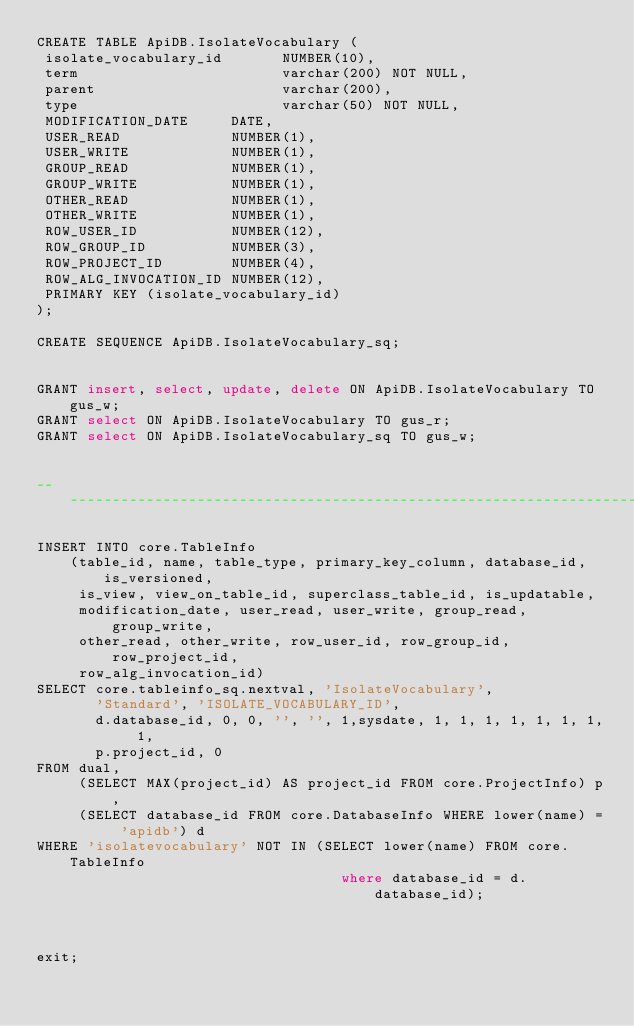Convert code to text. <code><loc_0><loc_0><loc_500><loc_500><_SQL_>CREATE TABLE ApiDB.IsolateVocabulary (
 isolate_vocabulary_id       NUMBER(10),
 term                        varchar(200) NOT NULL,
 parent                      varchar(200),
 type                        varchar(50) NOT NULL,
 MODIFICATION_DATE     DATE,
 USER_READ             NUMBER(1),
 USER_WRITE            NUMBER(1),
 GROUP_READ            NUMBER(1),
 GROUP_WRITE           NUMBER(1),
 OTHER_READ            NUMBER(1),
 OTHER_WRITE           NUMBER(1),
 ROW_USER_ID           NUMBER(12),
 ROW_GROUP_ID          NUMBER(3),
 ROW_PROJECT_ID        NUMBER(4),
 ROW_ALG_INVOCATION_ID NUMBER(12),
 PRIMARY KEY (isolate_vocabulary_id)
);

CREATE SEQUENCE ApiDB.IsolateVocabulary_sq;


GRANT insert, select, update, delete ON ApiDB.IsolateVocabulary TO gus_w;
GRANT select ON ApiDB.IsolateVocabulary TO gus_r;
GRANT select ON ApiDB.IsolateVocabulary_sq TO gus_w;


------------------------------------------------------------------------------

INSERT INTO core.TableInfo
    (table_id, name, table_type, primary_key_column, database_id, is_versioned,
     is_view, view_on_table_id, superclass_table_id, is_updatable, 
     modification_date, user_read, user_write, group_read, group_write, 
     other_read, other_write, row_user_id, row_group_id, row_project_id, 
     row_alg_invocation_id)
SELECT core.tableinfo_sq.nextval, 'IsolateVocabulary',
       'Standard', 'ISOLATE_VOCABULARY_ID',
       d.database_id, 0, 0, '', '', 1,sysdate, 1, 1, 1, 1, 1, 1, 1, 1,
       p.project_id, 0
FROM dual,
     (SELECT MAX(project_id) AS project_id FROM core.ProjectInfo) p,
     (SELECT database_id FROM core.DatabaseInfo WHERE lower(name) = 'apidb') d
WHERE 'isolatevocabulary' NOT IN (SELECT lower(name) FROM core.TableInfo
                                    where database_id = d.database_id);



exit;
</code> 